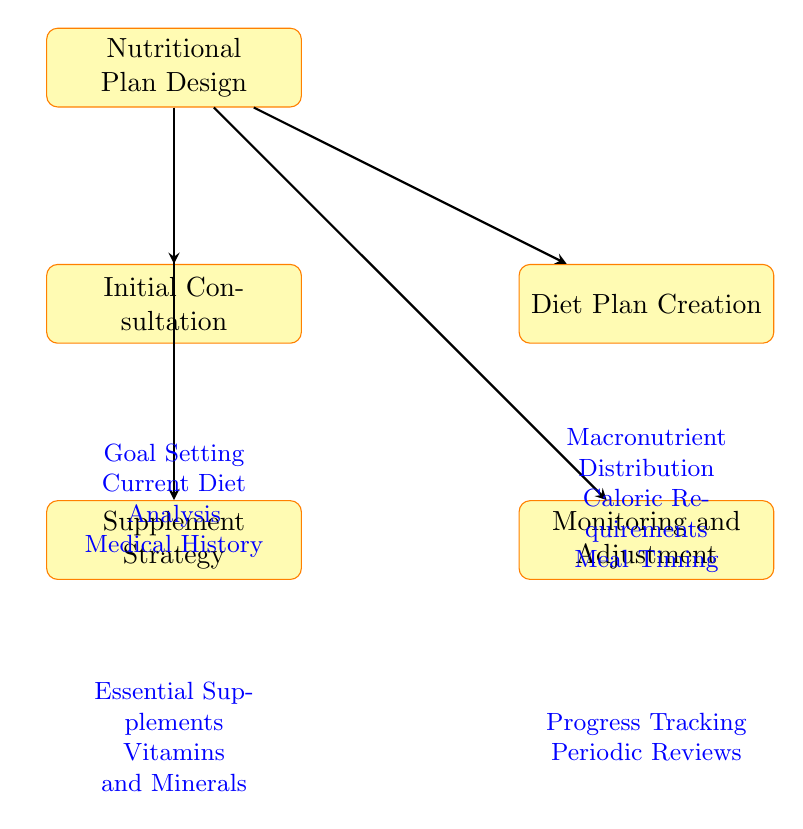What are the four main components of the nutritional plan design? The diagram outlines four main components starting from "Nutritional Plan Design" which branches into "Initial Consultation", "Diet Plan Creation", "Supplement Strategy", and "Monitoring and Adjustment".
Answer: Initial Consultation, Diet Plan Creation, Supplement Strategy, Monitoring and Adjustment How many sub-elements are listed under "Initial Consultation"? The diagram details three sub-elements for "Initial Consultation": "Goal Setting", "Current Diet Analysis", and "Medical History", confirming a total of three sub-elements.
Answer: 3 What is one element included in the "Supplement Strategy"? In the diagram, one of the sub-elements of "Supplement Strategy" is "Essential Supplements", emphasizing the inclusion of crucial items like protein powder and BCAAs.
Answer: Essential Supplements Which component follows "Diet Plan Creation" in the flow? The diagram shows that "Monitoring and Adjustment" is to the right of "Supplement Strategy", indicating that after the diet plan is created, monitoring occurs as a subsequent step.
Answer: Monitoring and Adjustment What are the two sub-elements listed under "Monitoring and Adjustment"? Under "Monitoring and Adjustment", the diagram indicates two sub-elements: "Progress Tracking" and "Periodic Reviews", which are essential for adjusting the nutritional plan over time.
Answer: Progress Tracking, Periodic Reviews What type of nutritional assessment is performed during the "Initial Consultation"? The "Initial Consultation" component includes a "Current Diet Analysis", which assesses the existing macronutrient breakdown and caloric intake levels of the athlete.
Answer: Current Diet Analysis How many aspects are covered in "Diet Plan Creation"? Within "Diet Plan Creation", the diagram illustrates three key aspects: "Macronutrient Distribution", "Caloric Requirements", and "Meal Timing", which collectively guide the nutritional strategy.
Answer: 3 What is a key focus of "Progress Tracking" in the nutritional plan? The diagram specifies that "Progress Tracking" under "Monitoring and Adjustment" focuses on monitoring "Weight" and "Performance Metrics", which are crucial indicators of an athlete’s progress.
Answer: Weight, Performance Metrics 